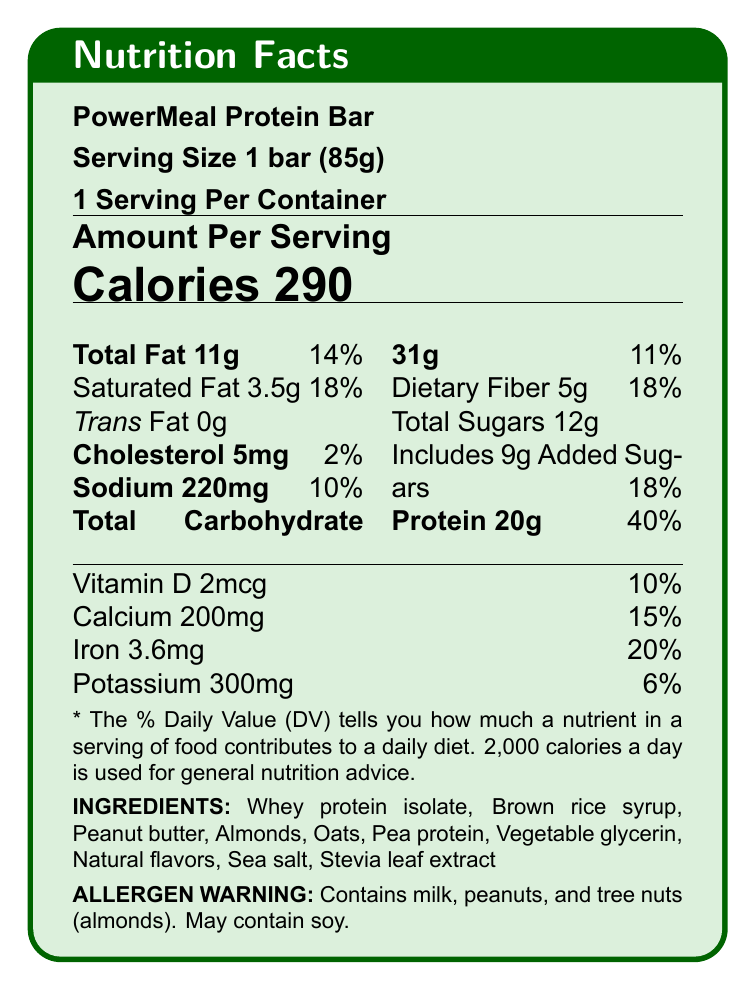what is the serving size for the PowerMeal Protein Bar? The document states that the serving size is "1 bar (85g)."
Answer: 1 bar (85g) how many calories are in one PowerMeal Protein Bar? The label specifies that there are 290 calories per serving, and each serving is one bar.
Answer: 290 calories what percentage of the daily value of protein does one PowerMeal Protein Bar provide? According to the document, one PowerMeal Protein Bar provides 40% of the daily value for protein.
Answer: 40% what are the total grams of fat in one PowerMeal Protein Bar? The label indicates that there are 11 grams of total fat per bar.
Answer: 11g how much sodium is in one serving of the PowerMeal Protein Bar? The label lists the sodium content as 220 mg per serving.
Answer: 220 mg which of the following is NOT an ingredient in the PowerMeal Protein Bar? A. Whey Protein Isolate B. Brown Rice Syrup C. Corn Syrup D. Almonds Corn syrup is not listed among the ingredients in the document.
Answer: C. Corn Syrup what percentage of the daily value of calcium does one PowerMeal Protein Bar provide? A. 15% B. 10% C. 20% D. 6% The document states that one bar provides 15% of the daily value for calcium.
Answer: A. 15% does the PowerMeal Protein Bar contain trans fat? The label clearly states that the amount of trans fat is 0 grams.
Answer: No summarize the nutritional benefits and drawbacks of the PowerMeal Protein Bar as listed in the nutritional analysis. This summary description is derived from the points listed under "positives" and "negatives" in the nutritional analysis section.
Answer: The PowerMeal Protein Bar is high in protein, a good source of dietary fiber, and contains essential vitamins and minerals while being low in cholesterol. However, it is relatively high in calories, contains added sugars, and has a moderate sodium content. does the PowerMeal Protein Bar contain any allergens? The label includes an allergen warning that states the bar contains milk, peanuts, and tree nuts (almonds), and may contain soy.
Answer: Yes how much fiber is in one serving of the PowerMeal Protein Bar? The document specifies that there are 5 grams of dietary fiber in one bar.
Answer: 5g is the PowerMeal Protein Bar suitable for someone trying to reduce sugar intake? The bar contains 12 grams of total sugars, including 9 grams of added sugars, which might not be suitable for someone looking to reduce sugar intake.
Answer: No can you determine the price of the PowerMeal Protein Bar from this document? The document provides nutritional information but does not mention the price.
Answer: Not enough information what educational topics does the document suggest for local initiatives? The document lists these as suggested educational topics for local initiatives.
Answer: Understanding macro and micronutrients, balanced meal planning, reading and interpreting nutrition labels, importance of protein in daily diet how much iron is in the PowerMeal Protein Bar? The label indicates that there are 3.6 mg of iron in one bar, which is 20% of the daily value.
Answer: 3.6 mg what local initiatives are relevant to the community according to the document? The document specifically mentions these initiatives under the community relevance section.
Answer: Healthy eating workshops for busy professionals, nutrition education for senior citizens, sports nutrition seminars for local athletes, meal planning classes for families on a budget is the PowerMeal Protein Bar low in cholesterol? The bar contains only 5 mg of cholesterol, which is 2% of the daily value, indicating it is low in cholesterol.
Answer: Yes 